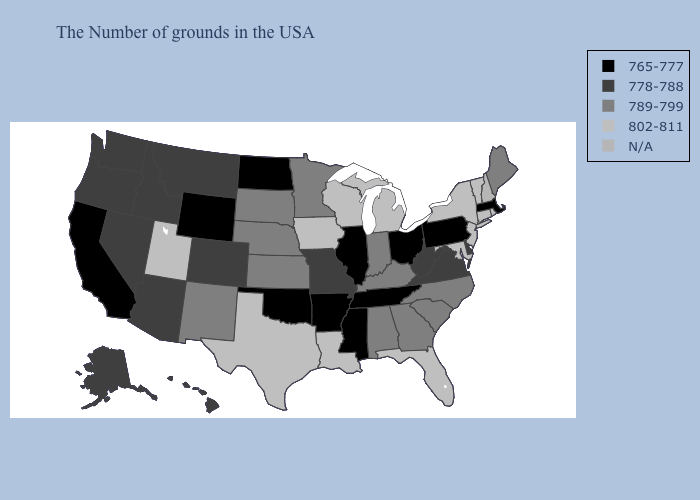What is the value of North Dakota?
Quick response, please. 765-777. Among the states that border Arkansas , does Oklahoma have the lowest value?
Quick response, please. Yes. Does Missouri have the lowest value in the MidWest?
Write a very short answer. No. Name the states that have a value in the range 802-811?
Short answer required. Rhode Island, Vermont, Connecticut, New York, New Jersey, Maryland, Florida, Michigan, Wisconsin, Louisiana, Iowa, Texas, Utah. Which states hav the highest value in the MidWest?
Write a very short answer. Michigan, Wisconsin, Iowa. What is the value of Oregon?
Write a very short answer. 778-788. What is the value of Hawaii?
Be succinct. 778-788. Does the map have missing data?
Keep it brief. Yes. What is the highest value in the USA?
Concise answer only. 802-811. Is the legend a continuous bar?
Quick response, please. No. What is the lowest value in the USA?
Be succinct. 765-777. What is the highest value in the USA?
Write a very short answer. 802-811. What is the lowest value in the USA?
Keep it brief. 765-777. Does Massachusetts have the lowest value in the Northeast?
Answer briefly. Yes. 